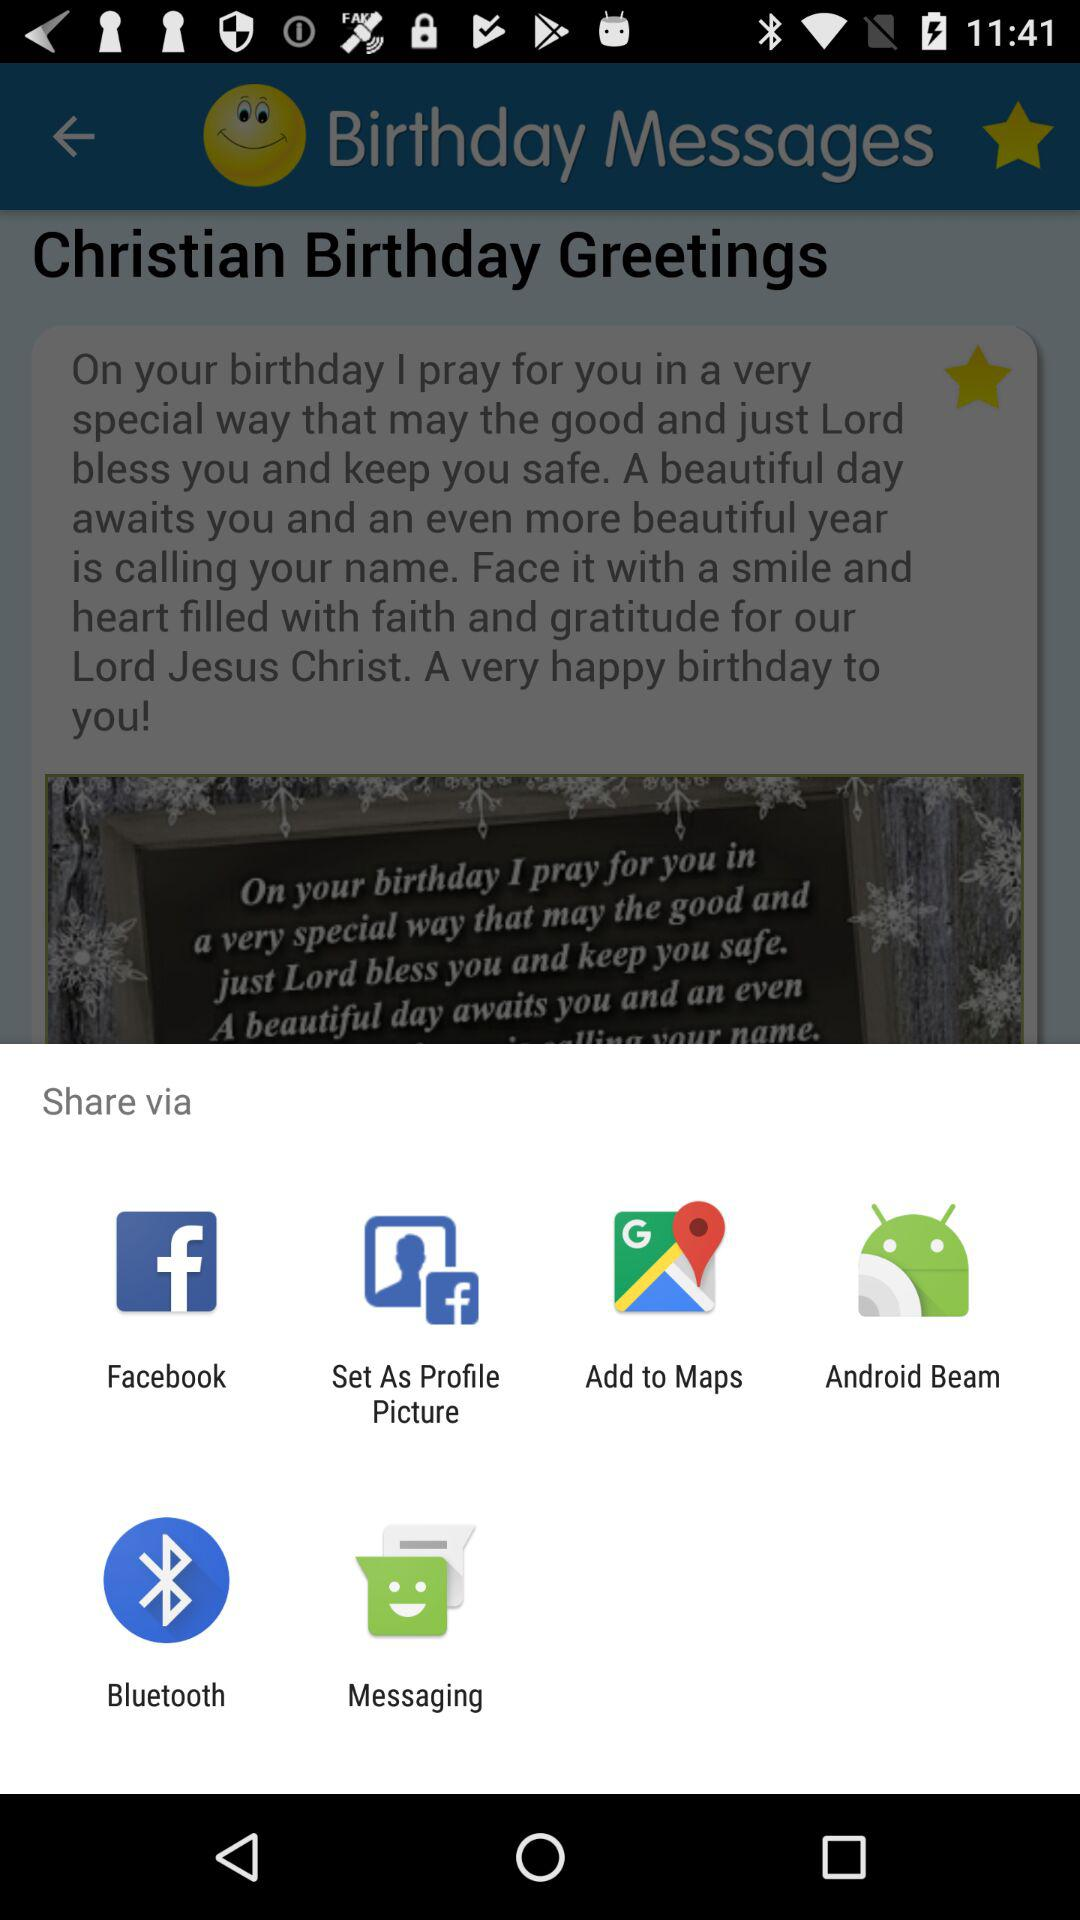Through what applications can we share? You can share through "Facebook", "Set As Profile Picture", "Add to Maps", "Android Beam", "Bluetooth" and "Messaging". 